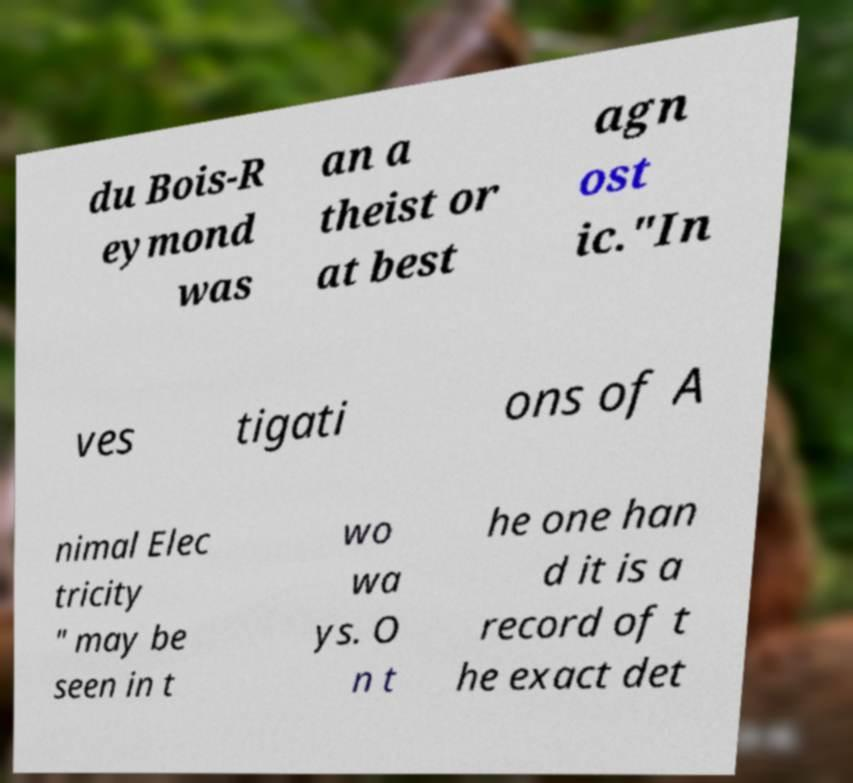For documentation purposes, I need the text within this image transcribed. Could you provide that? du Bois-R eymond was an a theist or at best agn ost ic."In ves tigati ons of A nimal Elec tricity " may be seen in t wo wa ys. O n t he one han d it is a record of t he exact det 